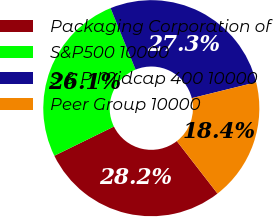Convert chart. <chart><loc_0><loc_0><loc_500><loc_500><pie_chart><fcel>Packaging Corporation of<fcel>S&P500 10000<fcel>S & P Midcap 400 10000<fcel>Peer Group 10000<nl><fcel>28.24%<fcel>26.1%<fcel>27.3%<fcel>18.36%<nl></chart> 